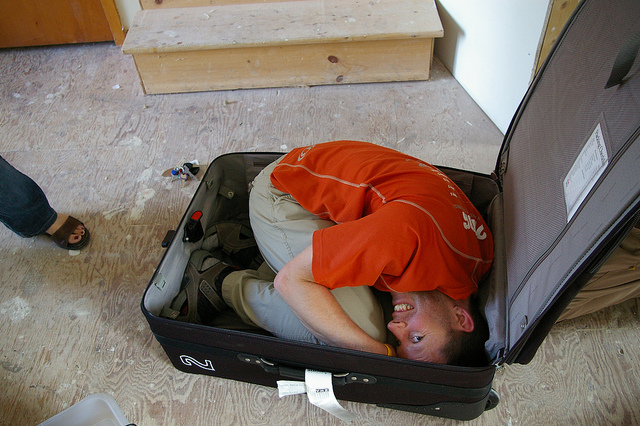Extract all visible text content from this image. 2 